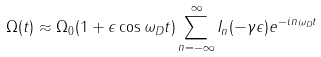Convert formula to latex. <formula><loc_0><loc_0><loc_500><loc_500>\Omega ( t ) \approx \Omega _ { 0 } ( 1 + \epsilon \cos \omega _ { D } t ) \sum _ { n = - \infty } ^ { \infty } I _ { n } ( - \gamma \epsilon ) e ^ { - i n \omega _ { D } t }</formula> 